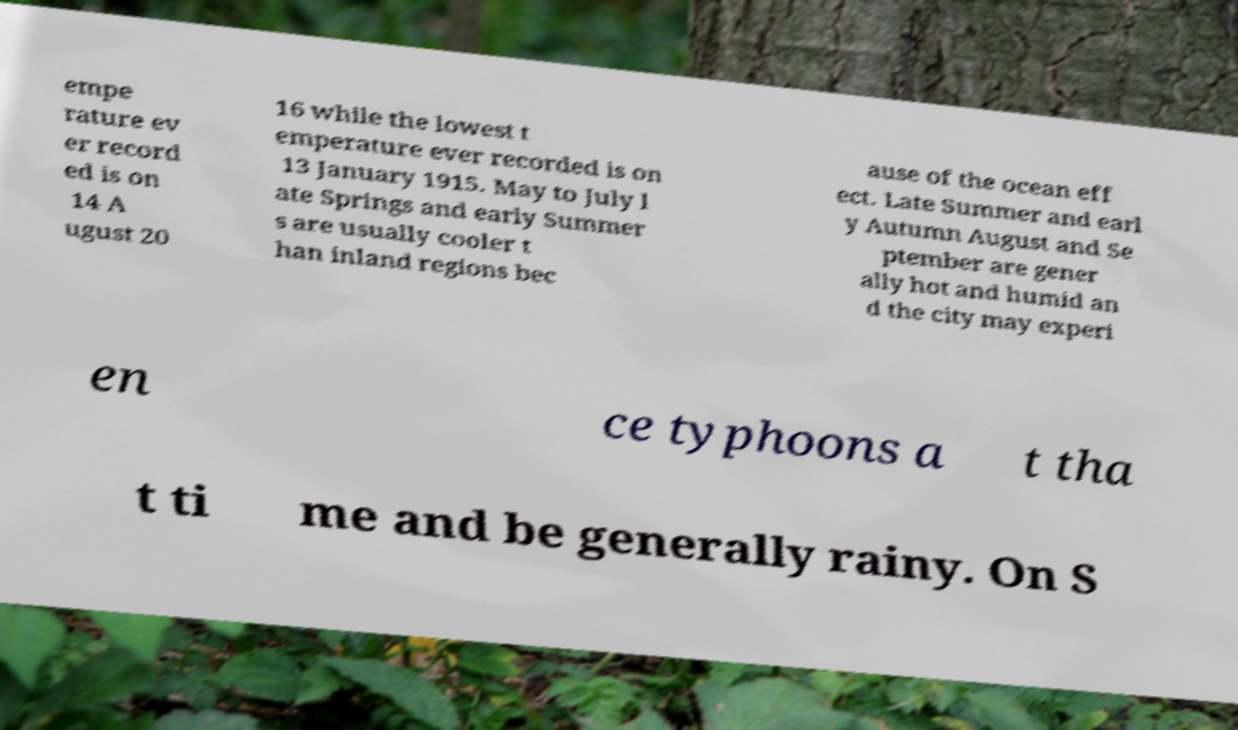Can you accurately transcribe the text from the provided image for me? empe rature ev er record ed is on 14 A ugust 20 16 while the lowest t emperature ever recorded is on 13 January 1915. May to July l ate Springs and early Summer s are usually cooler t han inland regions bec ause of the ocean eff ect. Late Summer and earl y Autumn August and Se ptember are gener ally hot and humid an d the city may experi en ce typhoons a t tha t ti me and be generally rainy. On S 